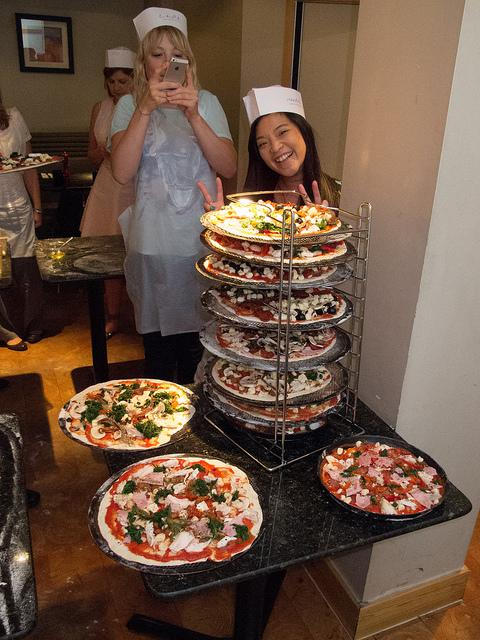What will these ladies next do with the pizzas?

Choices:
A) bake
B) serve
C) throw away
D) eat bake 